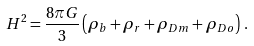Convert formula to latex. <formula><loc_0><loc_0><loc_500><loc_500>H ^ { 2 } = \frac { 8 \pi G } { 3 } \left ( \rho _ { b } + \rho _ { r } + \rho _ { D m } + \rho _ { D o } \right ) \, .</formula> 